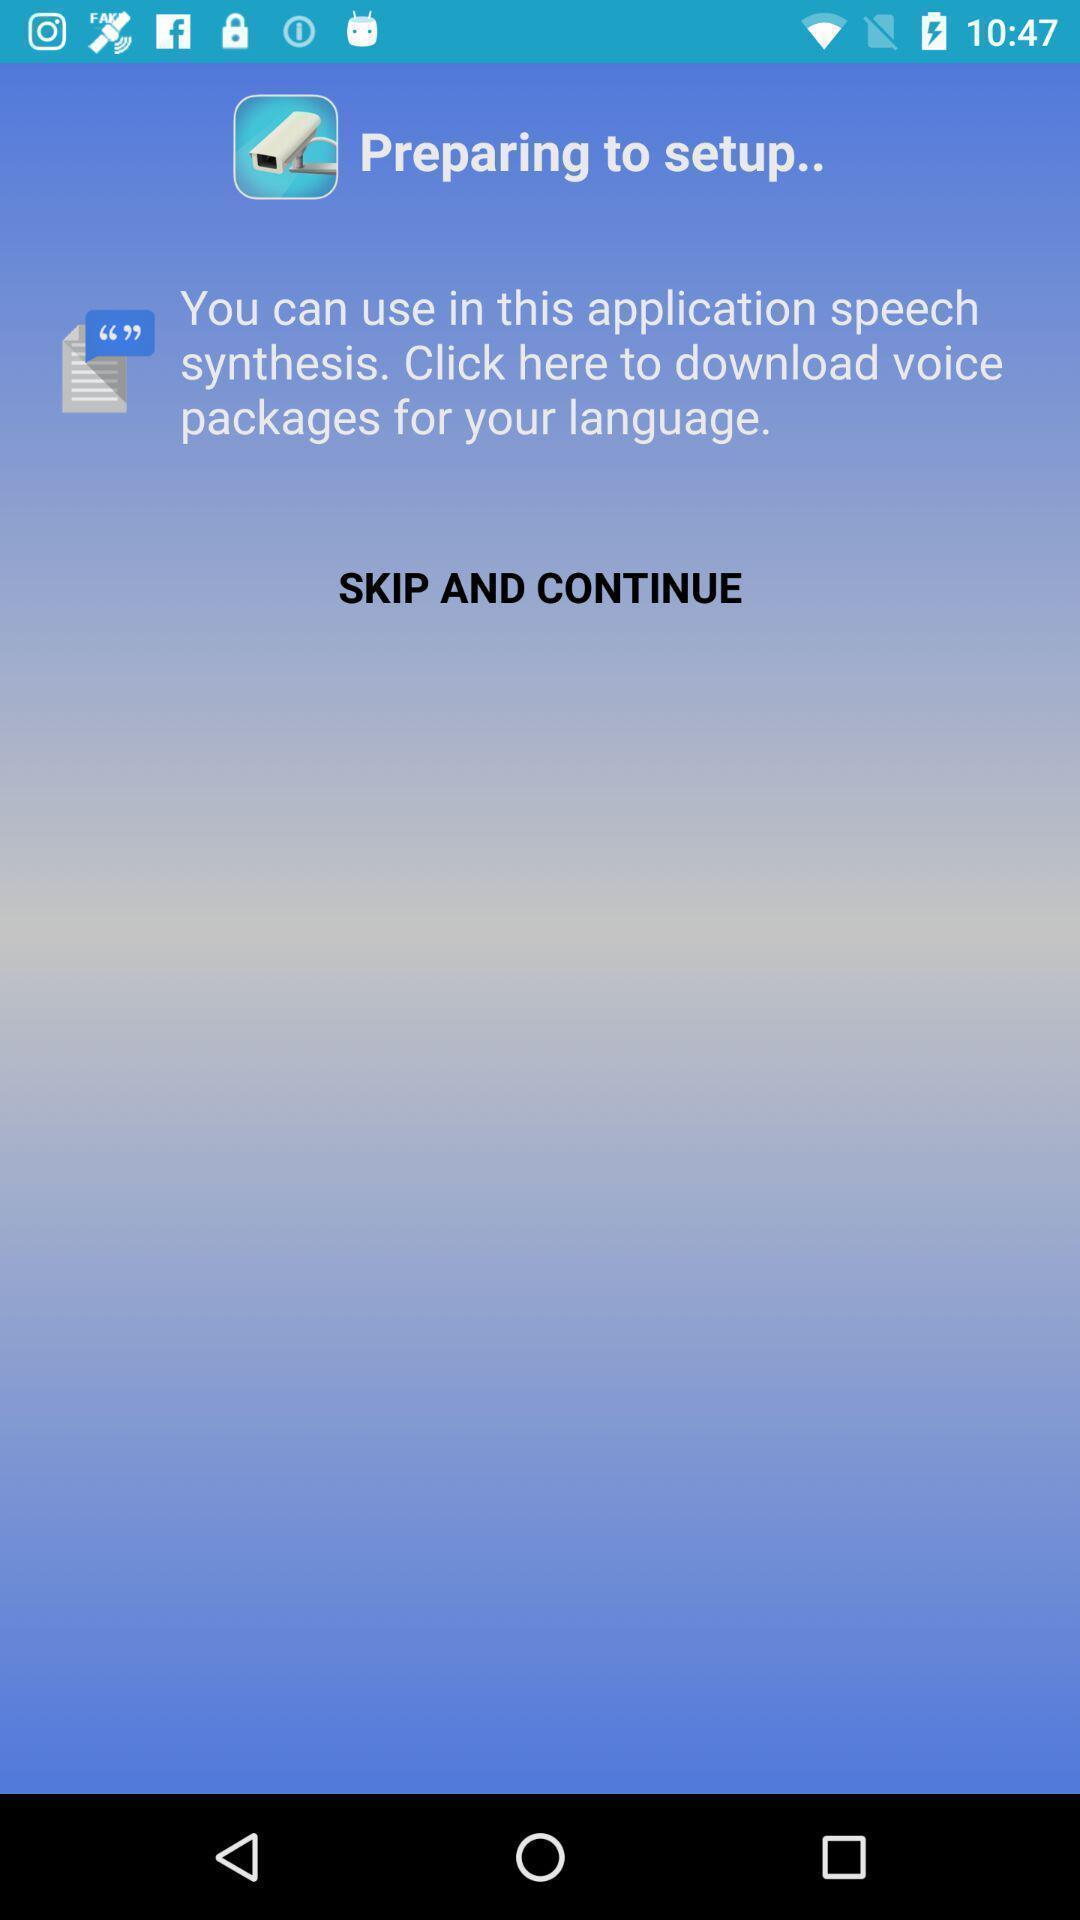Provide a detailed account of this screenshot. Welcome page. 